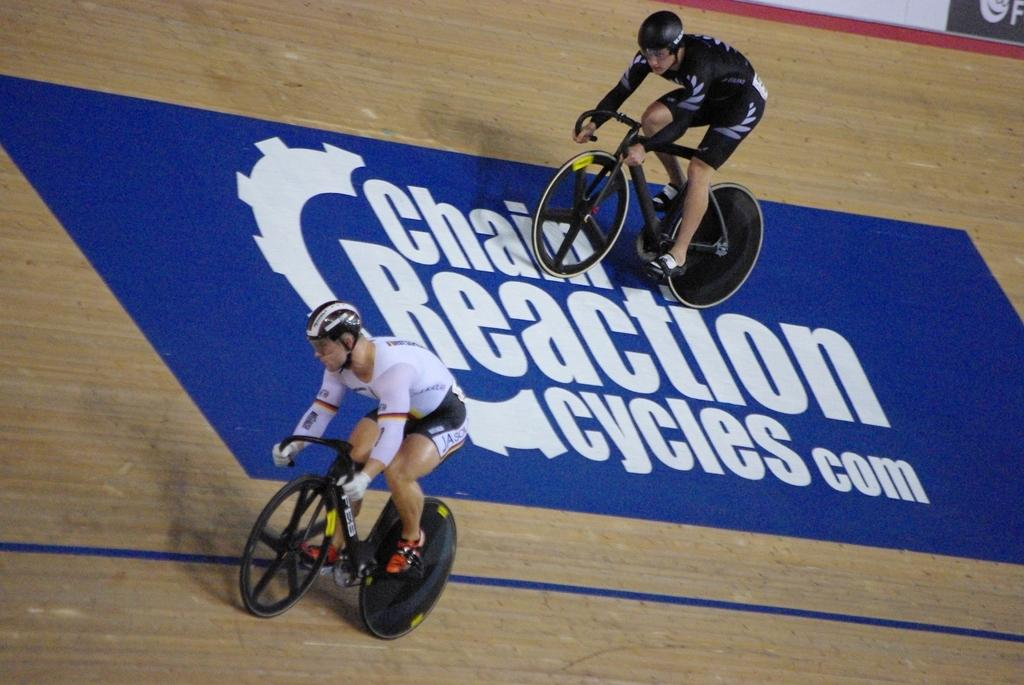Provide a one-sentence caption for the provided image. two people are riding bikes over a blue mat on the ground that says Chain Reaction and a website in white letters. 